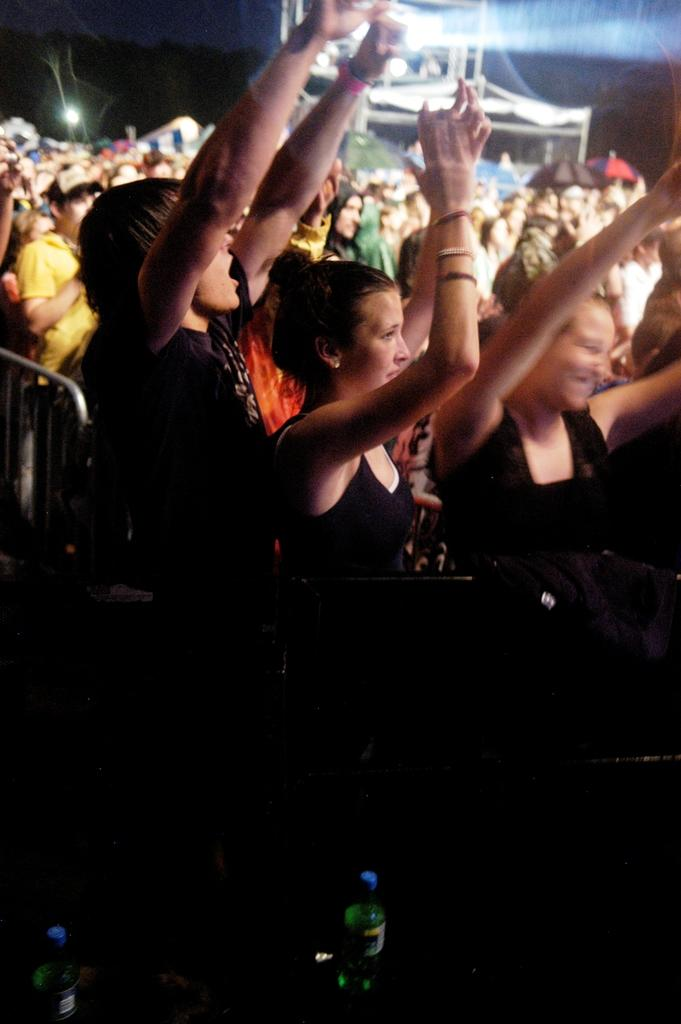Who or what can be seen in the image? There are people in the image. What objects are in the front of the image? There are two bottles in the front of the image. How would you describe the lighting in the image? The image appears to be a bit dark. What can be seen in the background of the image? There are lights visible in the background of the image. What type of argument is taking place between the coach and the passenger in the image? There is no coach or passenger present in the image, nor is there any argument taking place. 